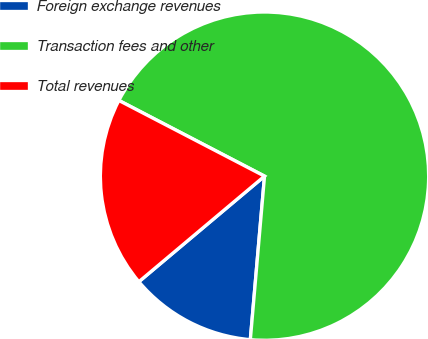Convert chart. <chart><loc_0><loc_0><loc_500><loc_500><pie_chart><fcel>Foreign exchange revenues<fcel>Transaction fees and other<fcel>Total revenues<nl><fcel>12.5%<fcel>68.75%<fcel>18.75%<nl></chart> 